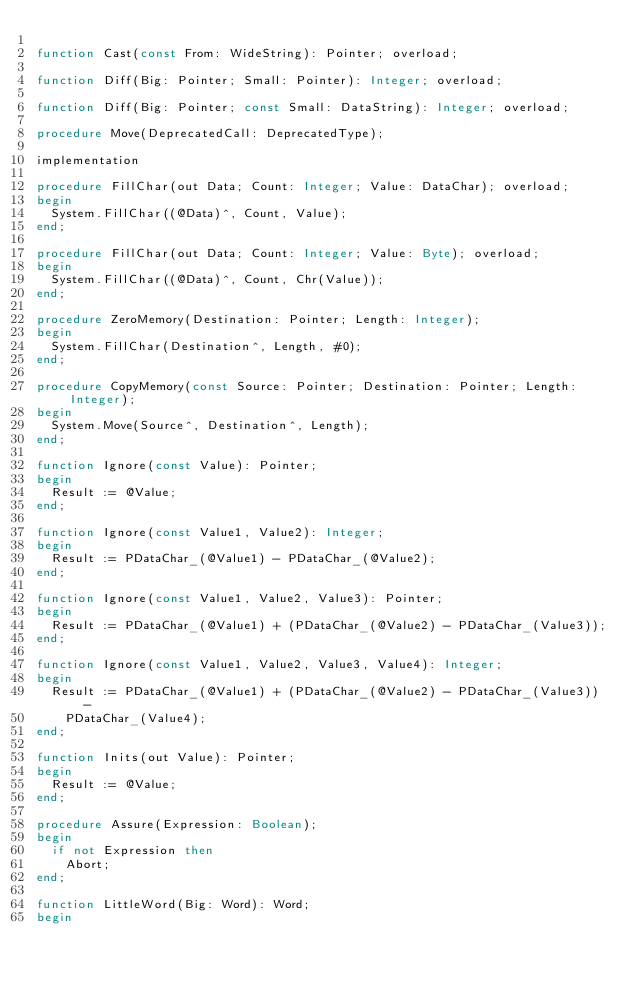Convert code to text. <code><loc_0><loc_0><loc_500><loc_500><_Pascal_>
function Cast(const From: WideString): Pointer; overload;

function Diff(Big: Pointer; Small: Pointer): Integer; overload;

function Diff(Big: Pointer; const Small: DataString): Integer; overload;

procedure Move(DeprecatedCall: DeprecatedType);

implementation

procedure FillChar(out Data; Count: Integer; Value: DataChar); overload;
begin
  System.FillChar((@Data)^, Count, Value);
end;

procedure FillChar(out Data; Count: Integer; Value: Byte); overload;
begin
  System.FillChar((@Data)^, Count, Chr(Value));
end;

procedure ZeroMemory(Destination: Pointer; Length: Integer);
begin
  System.FillChar(Destination^, Length, #0);
end;

procedure CopyMemory(const Source: Pointer; Destination: Pointer; Length: Integer);
begin
  System.Move(Source^, Destination^, Length);
end;

function Ignore(const Value): Pointer;
begin
  Result := @Value;
end;

function Ignore(const Value1, Value2): Integer;
begin
  Result := PDataChar_(@Value1) - PDataChar_(@Value2);
end;

function Ignore(const Value1, Value2, Value3): Pointer;
begin
  Result := PDataChar_(@Value1) + (PDataChar_(@Value2) - PDataChar_(Value3));
end;

function Ignore(const Value1, Value2, Value3, Value4): Integer;
begin
  Result := PDataChar_(@Value1) + (PDataChar_(@Value2) - PDataChar_(Value3)) -
    PDataChar_(Value4);
end;

function Inits(out Value): Pointer;
begin
  Result := @Value;
end;

procedure Assure(Expression: Boolean);
begin
  if not Expression then
    Abort;
end;

function LittleWord(Big: Word): Word;
begin</code> 